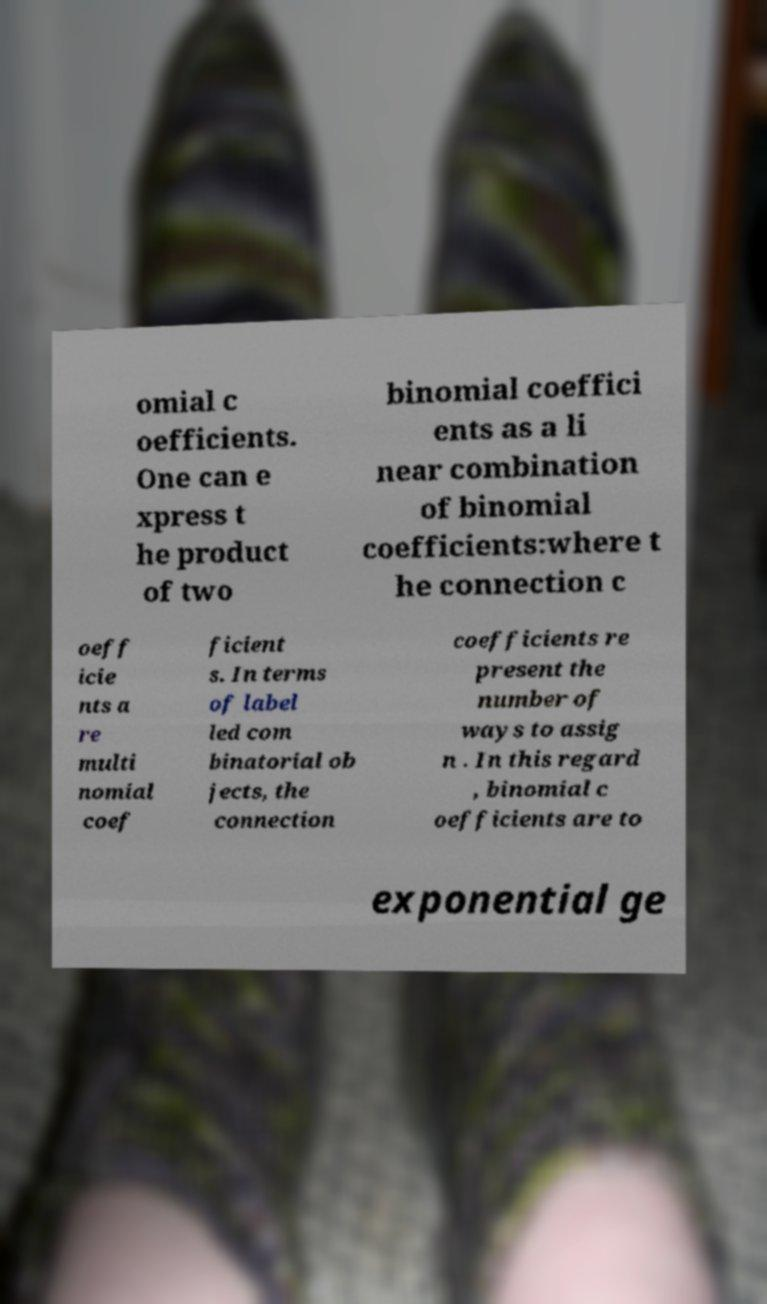For documentation purposes, I need the text within this image transcribed. Could you provide that? omial c oefficients. One can e xpress t he product of two binomial coeffici ents as a li near combination of binomial coefficients:where t he connection c oeff icie nts a re multi nomial coef ficient s. In terms of label led com binatorial ob jects, the connection coefficients re present the number of ways to assig n . In this regard , binomial c oefficients are to exponential ge 